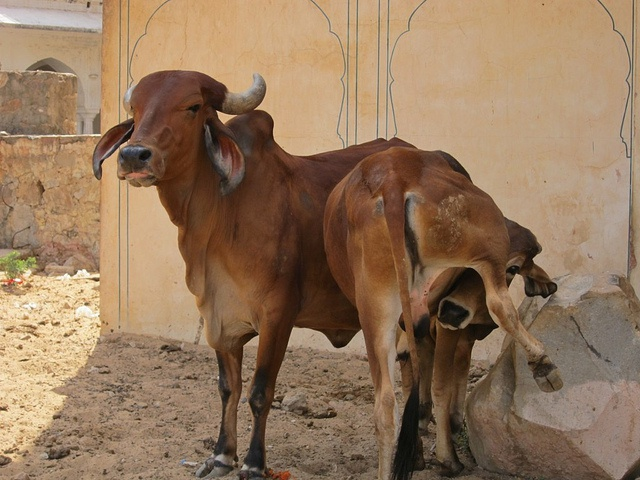Describe the objects in this image and their specific colors. I can see cow in darkgray, maroon, black, and gray tones, cow in darkgray, maroon, gray, and black tones, and cow in darkgray, maroon, black, and brown tones in this image. 